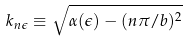<formula> <loc_0><loc_0><loc_500><loc_500>k _ { n \epsilon } \equiv \sqrt { \alpha ( \epsilon ) - ( n \pi / b ) ^ { 2 } }</formula> 